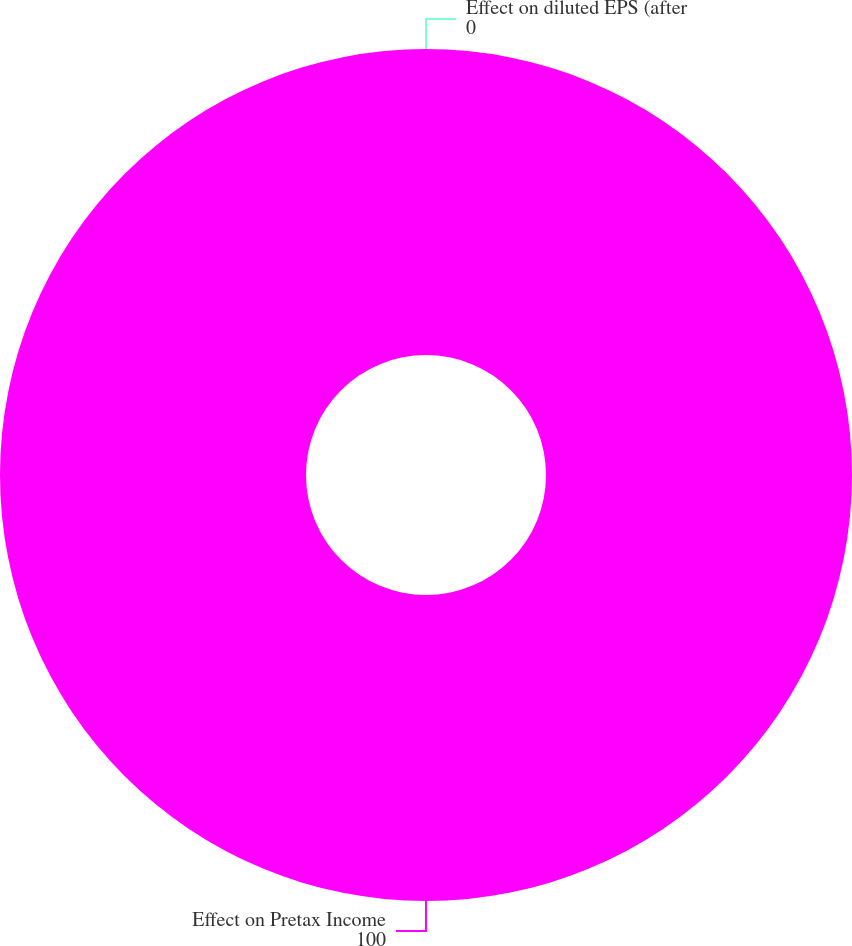Convert chart. <chart><loc_0><loc_0><loc_500><loc_500><pie_chart><fcel>Effect on Pretax Income<fcel>Effect on diluted EPS (after<nl><fcel>100.0%<fcel>0.0%<nl></chart> 